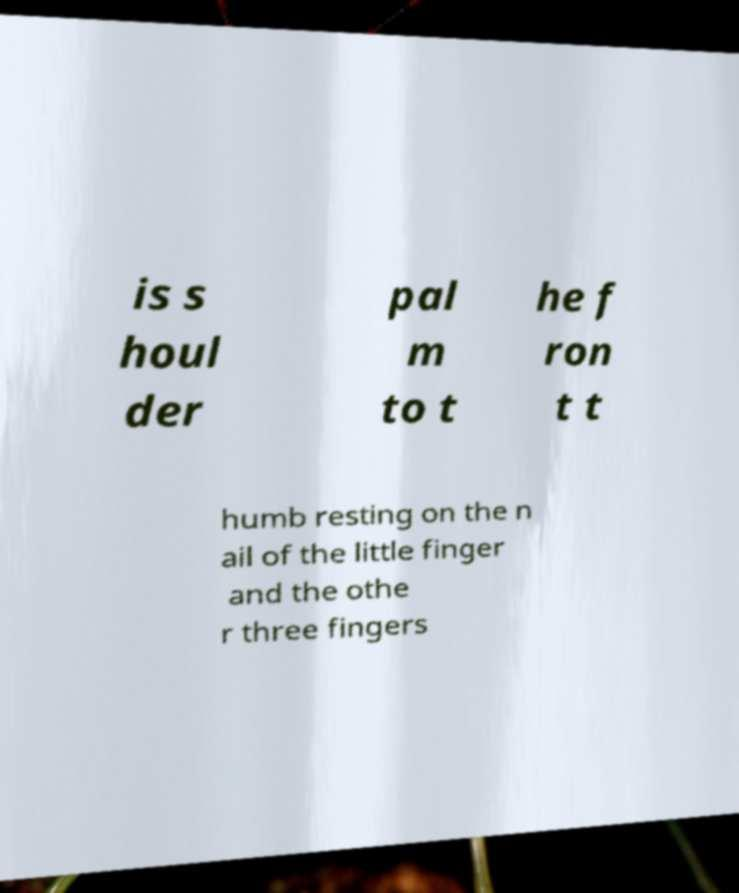What messages or text are displayed in this image? I need them in a readable, typed format. is s houl der pal m to t he f ron t t humb resting on the n ail of the little finger and the othe r three fingers 